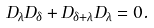Convert formula to latex. <formula><loc_0><loc_0><loc_500><loc_500>D _ { \lambda } D _ { \delta } + D _ { \delta + \lambda } D _ { \lambda } = 0 .</formula> 